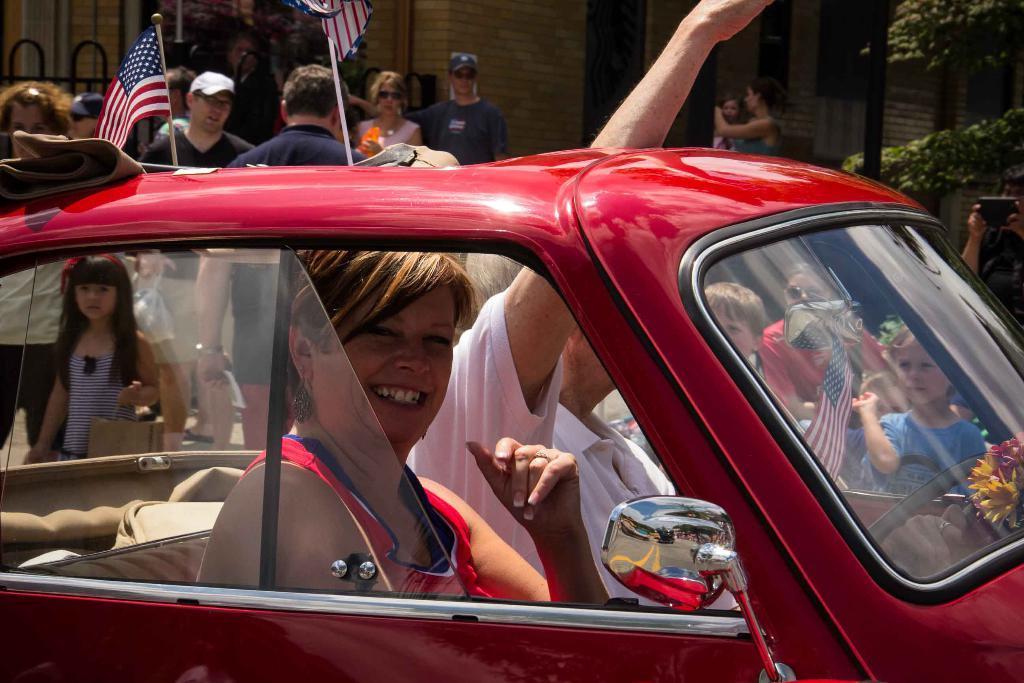In one or two sentences, can you explain what this image depicts? As we can see in the image there are few people, car, flag, building and tree. 